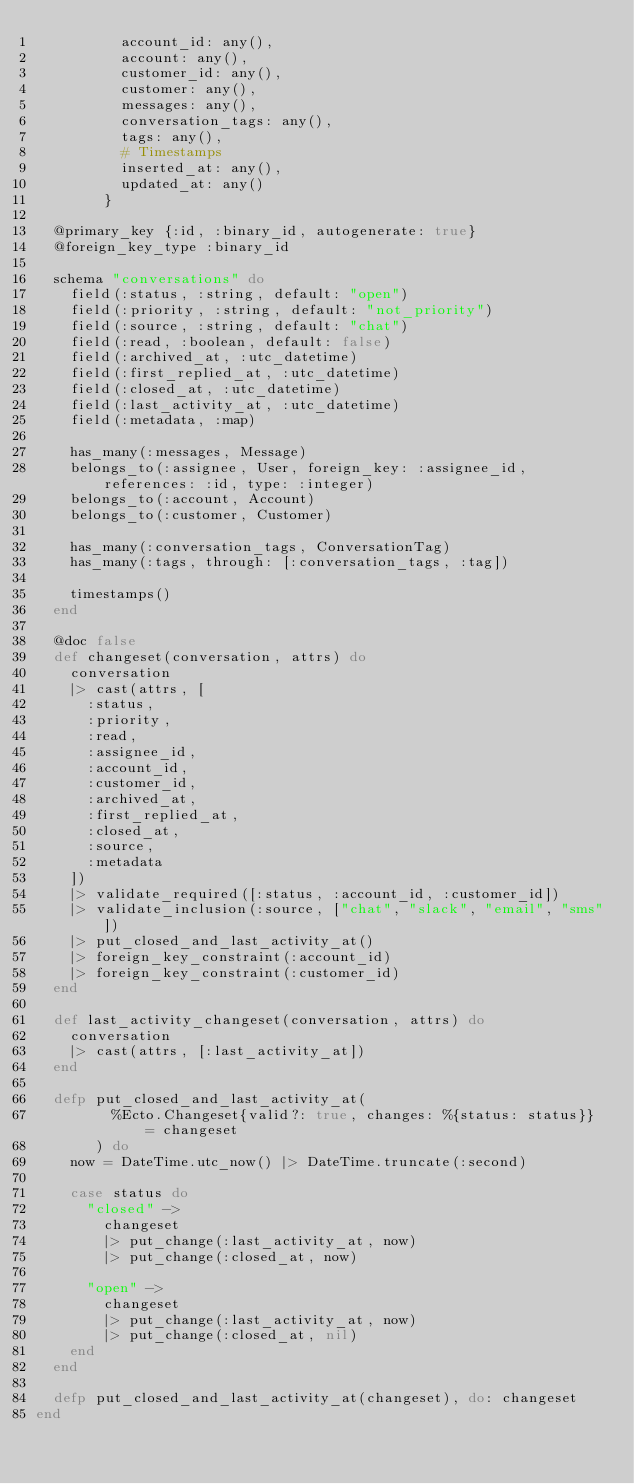<code> <loc_0><loc_0><loc_500><loc_500><_Elixir_>          account_id: any(),
          account: any(),
          customer_id: any(),
          customer: any(),
          messages: any(),
          conversation_tags: any(),
          tags: any(),
          # Timestamps
          inserted_at: any(),
          updated_at: any()
        }

  @primary_key {:id, :binary_id, autogenerate: true}
  @foreign_key_type :binary_id

  schema "conversations" do
    field(:status, :string, default: "open")
    field(:priority, :string, default: "not_priority")
    field(:source, :string, default: "chat")
    field(:read, :boolean, default: false)
    field(:archived_at, :utc_datetime)
    field(:first_replied_at, :utc_datetime)
    field(:closed_at, :utc_datetime)
    field(:last_activity_at, :utc_datetime)
    field(:metadata, :map)

    has_many(:messages, Message)
    belongs_to(:assignee, User, foreign_key: :assignee_id, references: :id, type: :integer)
    belongs_to(:account, Account)
    belongs_to(:customer, Customer)

    has_many(:conversation_tags, ConversationTag)
    has_many(:tags, through: [:conversation_tags, :tag])

    timestamps()
  end

  @doc false
  def changeset(conversation, attrs) do
    conversation
    |> cast(attrs, [
      :status,
      :priority,
      :read,
      :assignee_id,
      :account_id,
      :customer_id,
      :archived_at,
      :first_replied_at,
      :closed_at,
      :source,
      :metadata
    ])
    |> validate_required([:status, :account_id, :customer_id])
    |> validate_inclusion(:source, ["chat", "slack", "email", "sms"])
    |> put_closed_and_last_activity_at()
    |> foreign_key_constraint(:account_id)
    |> foreign_key_constraint(:customer_id)
  end

  def last_activity_changeset(conversation, attrs) do
    conversation
    |> cast(attrs, [:last_activity_at])
  end

  defp put_closed_and_last_activity_at(
         %Ecto.Changeset{valid?: true, changes: %{status: status}} = changeset
       ) do
    now = DateTime.utc_now() |> DateTime.truncate(:second)

    case status do
      "closed" ->
        changeset
        |> put_change(:last_activity_at, now)
        |> put_change(:closed_at, now)

      "open" ->
        changeset
        |> put_change(:last_activity_at, now)
        |> put_change(:closed_at, nil)
    end
  end

  defp put_closed_and_last_activity_at(changeset), do: changeset
end
</code> 